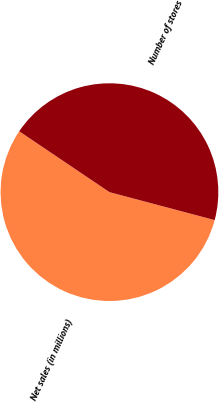Convert chart. <chart><loc_0><loc_0><loc_500><loc_500><pie_chart><fcel>Net sales (in millions)<fcel>Number of stores<nl><fcel>55.31%<fcel>44.69%<nl></chart> 